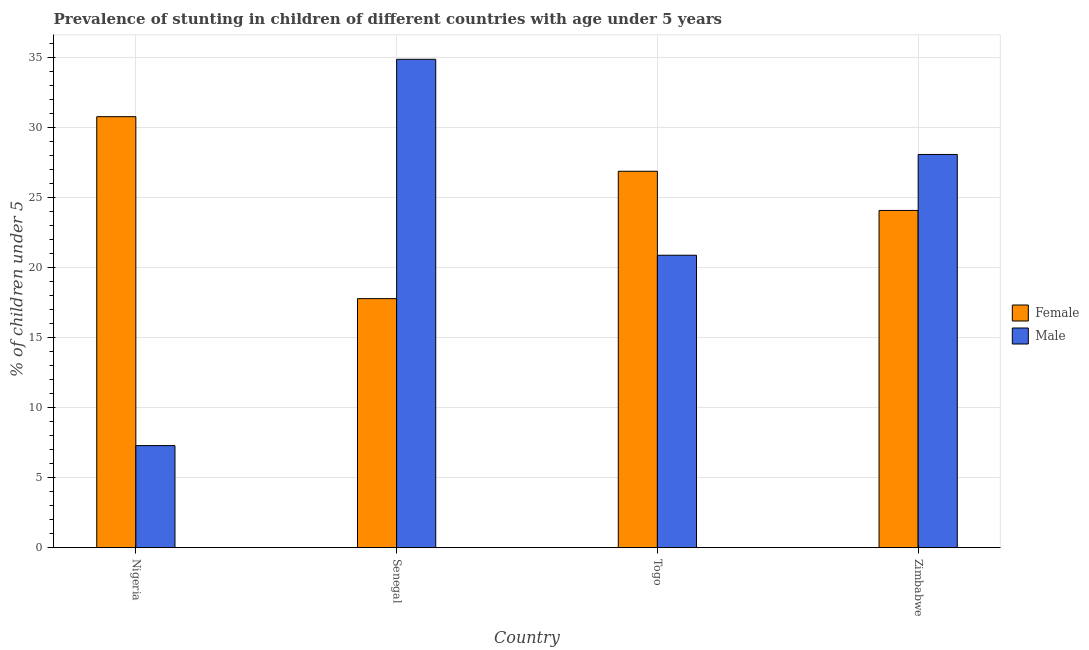How many different coloured bars are there?
Ensure brevity in your answer.  2. Are the number of bars on each tick of the X-axis equal?
Provide a short and direct response. Yes. How many bars are there on the 1st tick from the left?
Provide a succinct answer. 2. What is the label of the 1st group of bars from the left?
Provide a succinct answer. Nigeria. In how many cases, is the number of bars for a given country not equal to the number of legend labels?
Your response must be concise. 0. What is the percentage of stunted female children in Togo?
Make the answer very short. 26.9. Across all countries, what is the maximum percentage of stunted male children?
Offer a terse response. 34.9. Across all countries, what is the minimum percentage of stunted female children?
Your answer should be compact. 17.8. In which country was the percentage of stunted female children maximum?
Your response must be concise. Nigeria. In which country was the percentage of stunted female children minimum?
Make the answer very short. Senegal. What is the total percentage of stunted male children in the graph?
Give a very brief answer. 91.2. What is the difference between the percentage of stunted female children in Nigeria and that in Zimbabwe?
Provide a succinct answer. 6.7. What is the difference between the percentage of stunted female children in Togo and the percentage of stunted male children in Nigeria?
Ensure brevity in your answer.  19.6. What is the average percentage of stunted male children per country?
Offer a very short reply. 22.8. What is the difference between the percentage of stunted female children and percentage of stunted male children in Togo?
Offer a very short reply. 6. What is the ratio of the percentage of stunted male children in Senegal to that in Zimbabwe?
Provide a short and direct response. 1.24. Is the difference between the percentage of stunted female children in Nigeria and Togo greater than the difference between the percentage of stunted male children in Nigeria and Togo?
Ensure brevity in your answer.  Yes. What is the difference between the highest and the second highest percentage of stunted female children?
Ensure brevity in your answer.  3.9. Is the sum of the percentage of stunted female children in Senegal and Zimbabwe greater than the maximum percentage of stunted male children across all countries?
Provide a succinct answer. Yes. What does the 1st bar from the left in Togo represents?
Your answer should be compact. Female. Are all the bars in the graph horizontal?
Keep it short and to the point. No. Does the graph contain any zero values?
Your answer should be compact. No. Does the graph contain grids?
Your answer should be compact. Yes. How many legend labels are there?
Keep it short and to the point. 2. What is the title of the graph?
Offer a terse response. Prevalence of stunting in children of different countries with age under 5 years. Does "Netherlands" appear as one of the legend labels in the graph?
Make the answer very short. No. What is the label or title of the Y-axis?
Give a very brief answer.  % of children under 5. What is the  % of children under 5 of Female in Nigeria?
Keep it short and to the point. 30.8. What is the  % of children under 5 of Male in Nigeria?
Offer a terse response. 7.3. What is the  % of children under 5 of Female in Senegal?
Ensure brevity in your answer.  17.8. What is the  % of children under 5 in Male in Senegal?
Give a very brief answer. 34.9. What is the  % of children under 5 of Female in Togo?
Ensure brevity in your answer.  26.9. What is the  % of children under 5 in Male in Togo?
Offer a very short reply. 20.9. What is the  % of children under 5 in Female in Zimbabwe?
Ensure brevity in your answer.  24.1. What is the  % of children under 5 in Male in Zimbabwe?
Your response must be concise. 28.1. Across all countries, what is the maximum  % of children under 5 in Female?
Your answer should be compact. 30.8. Across all countries, what is the maximum  % of children under 5 in Male?
Provide a short and direct response. 34.9. Across all countries, what is the minimum  % of children under 5 in Female?
Your answer should be compact. 17.8. Across all countries, what is the minimum  % of children under 5 of Male?
Your answer should be very brief. 7.3. What is the total  % of children under 5 in Female in the graph?
Offer a very short reply. 99.6. What is the total  % of children under 5 of Male in the graph?
Your answer should be compact. 91.2. What is the difference between the  % of children under 5 in Male in Nigeria and that in Senegal?
Your answer should be very brief. -27.6. What is the difference between the  % of children under 5 of Male in Nigeria and that in Togo?
Make the answer very short. -13.6. What is the difference between the  % of children under 5 in Male in Nigeria and that in Zimbabwe?
Provide a short and direct response. -20.8. What is the difference between the  % of children under 5 in Male in Senegal and that in Togo?
Provide a short and direct response. 14. What is the difference between the  % of children under 5 of Male in Senegal and that in Zimbabwe?
Give a very brief answer. 6.8. What is the difference between the  % of children under 5 of Female in Senegal and the  % of children under 5 of Male in Togo?
Your response must be concise. -3.1. What is the difference between the  % of children under 5 in Female in Senegal and the  % of children under 5 in Male in Zimbabwe?
Provide a succinct answer. -10.3. What is the average  % of children under 5 of Female per country?
Offer a very short reply. 24.9. What is the average  % of children under 5 in Male per country?
Make the answer very short. 22.8. What is the difference between the  % of children under 5 of Female and  % of children under 5 of Male in Senegal?
Your response must be concise. -17.1. What is the difference between the  % of children under 5 of Female and  % of children under 5 of Male in Togo?
Give a very brief answer. 6. What is the difference between the  % of children under 5 in Female and  % of children under 5 in Male in Zimbabwe?
Give a very brief answer. -4. What is the ratio of the  % of children under 5 in Female in Nigeria to that in Senegal?
Offer a very short reply. 1.73. What is the ratio of the  % of children under 5 in Male in Nigeria to that in Senegal?
Provide a short and direct response. 0.21. What is the ratio of the  % of children under 5 in Female in Nigeria to that in Togo?
Give a very brief answer. 1.15. What is the ratio of the  % of children under 5 in Male in Nigeria to that in Togo?
Offer a very short reply. 0.35. What is the ratio of the  % of children under 5 in Female in Nigeria to that in Zimbabwe?
Ensure brevity in your answer.  1.28. What is the ratio of the  % of children under 5 of Male in Nigeria to that in Zimbabwe?
Keep it short and to the point. 0.26. What is the ratio of the  % of children under 5 in Female in Senegal to that in Togo?
Provide a short and direct response. 0.66. What is the ratio of the  % of children under 5 in Male in Senegal to that in Togo?
Offer a terse response. 1.67. What is the ratio of the  % of children under 5 of Female in Senegal to that in Zimbabwe?
Make the answer very short. 0.74. What is the ratio of the  % of children under 5 in Male in Senegal to that in Zimbabwe?
Your answer should be very brief. 1.24. What is the ratio of the  % of children under 5 in Female in Togo to that in Zimbabwe?
Offer a terse response. 1.12. What is the ratio of the  % of children under 5 in Male in Togo to that in Zimbabwe?
Make the answer very short. 0.74. What is the difference between the highest and the second highest  % of children under 5 of Male?
Give a very brief answer. 6.8. What is the difference between the highest and the lowest  % of children under 5 in Male?
Your answer should be compact. 27.6. 